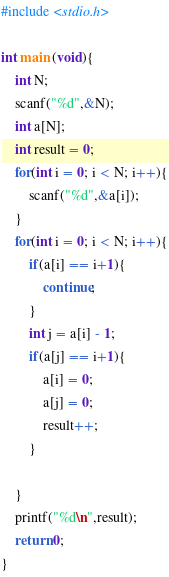Convert code to text. <code><loc_0><loc_0><loc_500><loc_500><_C_>#include <stdio.h>

int main (void){
	int N;
	scanf("%d",&N);
	int a[N];
	int result = 0;
	for(int i = 0; i < N; i++){
		scanf("%d",&a[i]);
	}
	for(int i = 0; i < N; i++){
		if(a[i] == i+1){
			continue;
		}
		int j = a[i] - 1;
		if(a[j] == i+1){
			a[i] = 0;
			a[j] = 0;
			result++;
		}
			
	}
	printf("%d\n",result);
	return 0;
}
</code> 